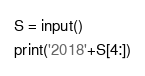<code> <loc_0><loc_0><loc_500><loc_500><_Python_>S = input()
print('2018'+S[4:])
</code> 